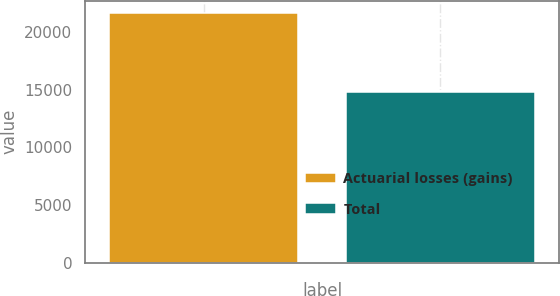Convert chart to OTSL. <chart><loc_0><loc_0><loc_500><loc_500><bar_chart><fcel>Actuarial losses (gains)<fcel>Total<nl><fcel>21630<fcel>14832<nl></chart> 